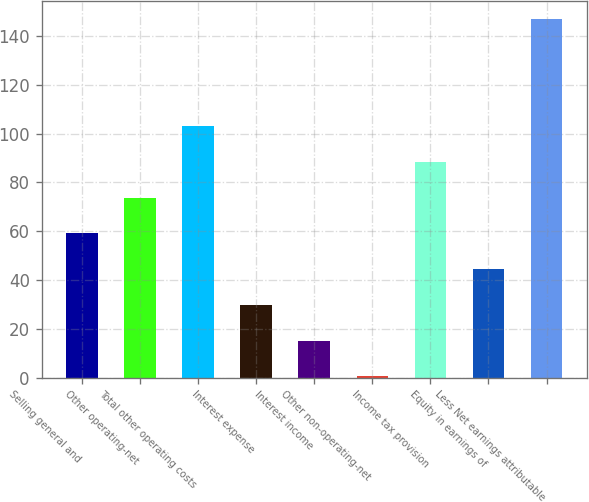Convert chart to OTSL. <chart><loc_0><loc_0><loc_500><loc_500><bar_chart><fcel>Selling general and<fcel>Other operating-net<fcel>Total other operating costs<fcel>Interest expense<fcel>Interest income<fcel>Other non-operating-net<fcel>Income tax provision<fcel>Equity in earnings of<fcel>Less Net earnings attributable<nl><fcel>59.14<fcel>73.8<fcel>103.12<fcel>29.82<fcel>15.16<fcel>0.5<fcel>88.46<fcel>44.48<fcel>147.1<nl></chart> 